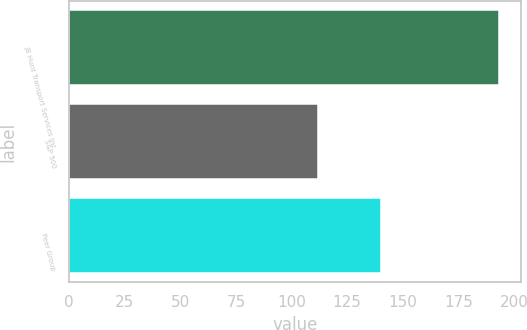<chart> <loc_0><loc_0><loc_500><loc_500><bar_chart><fcel>JB Hunt Transport Services Inc<fcel>S&P 500<fcel>Peer Group<nl><fcel>193.45<fcel>111.99<fcel>140.35<nl></chart> 